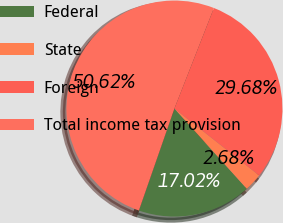Convert chart to OTSL. <chart><loc_0><loc_0><loc_500><loc_500><pie_chart><fcel>Federal<fcel>State<fcel>Foreign<fcel>Total income tax provision<nl><fcel>17.02%<fcel>2.68%<fcel>29.68%<fcel>50.62%<nl></chart> 